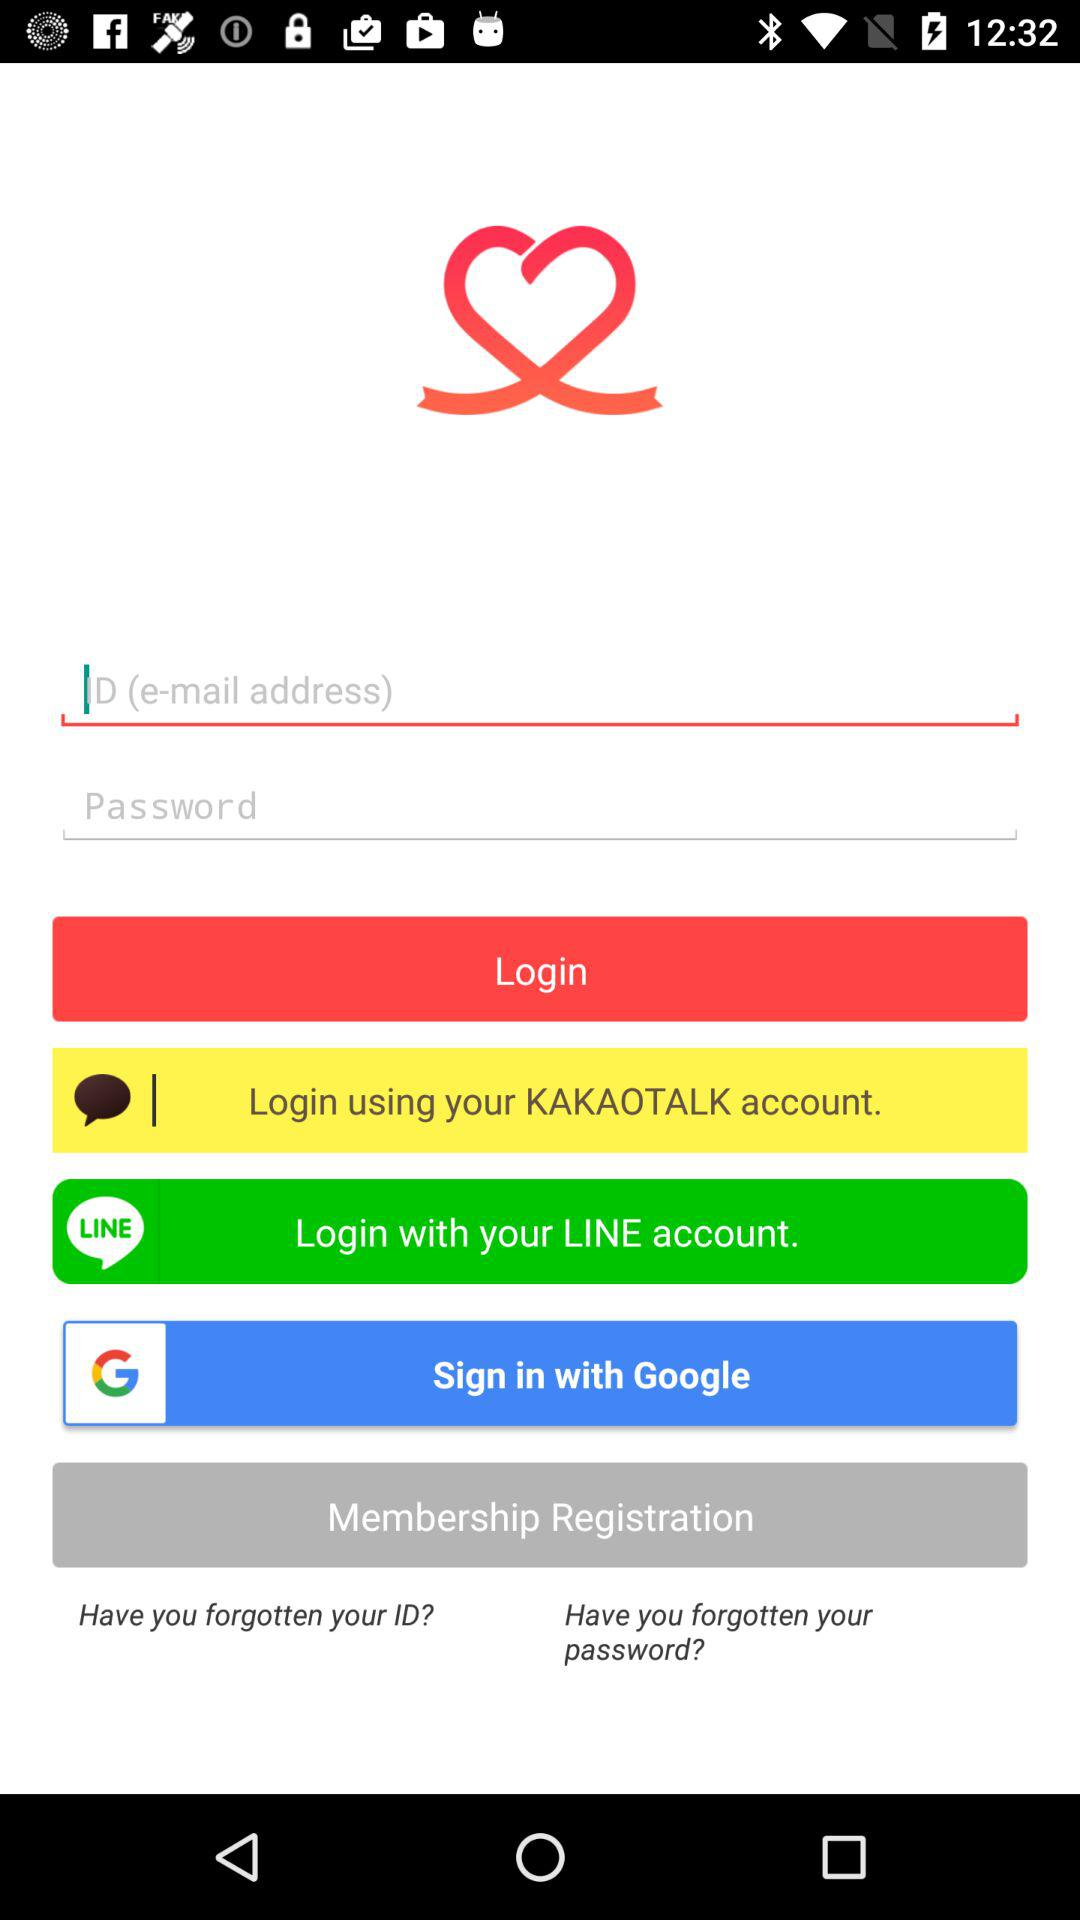What are the options to login? The options are "KAKAOTALK account", "LINE account" and "Google". 